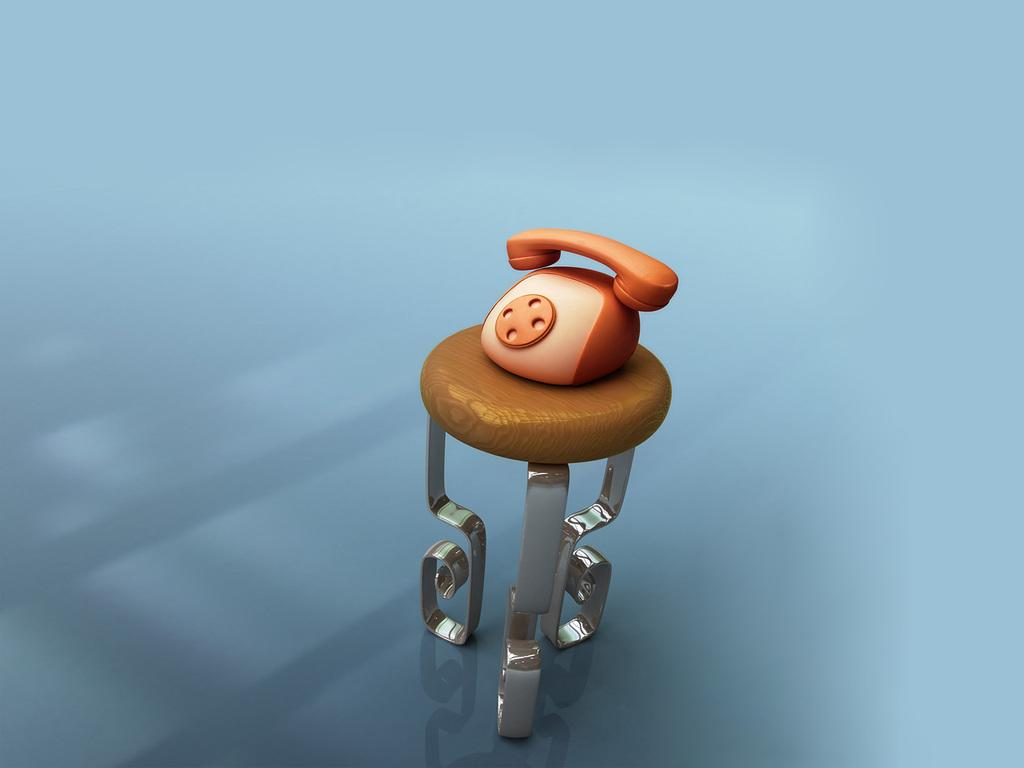What type of furniture is present in the image? There is a table in the image. What object is placed on the table? There is a phone toy placed on the table. What type of jar can be seen in the scene? There is no jar present in the image; it only features a table with a phone toy on it. 